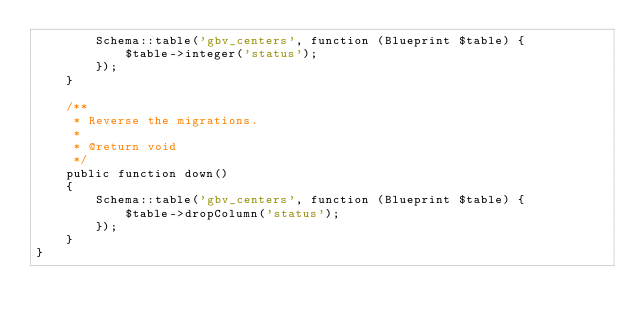<code> <loc_0><loc_0><loc_500><loc_500><_PHP_>        Schema::table('gbv_centers', function (Blueprint $table) {
            $table->integer('status');
        });
    }

    /**
     * Reverse the migrations.
     *
     * @return void
     */
    public function down()
    {
        Schema::table('gbv_centers', function (Blueprint $table) {
            $table->dropColumn('status');
        });
    }
}
</code> 